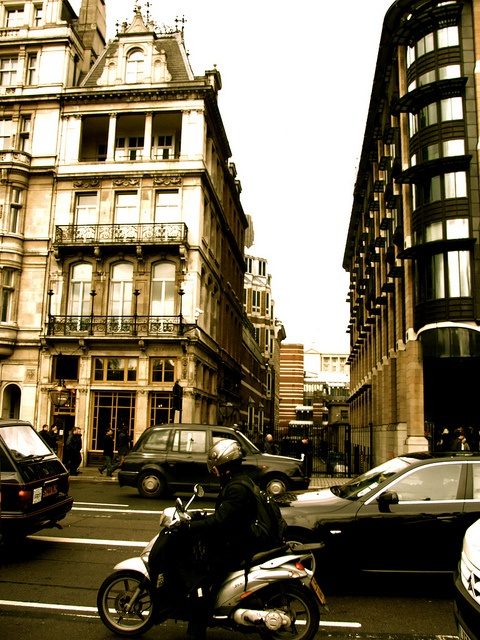Describe the objects in this image and their specific colors. I can see car in tan, black, olive, and white tones, motorcycle in tan, black, olive, and white tones, people in tan, black, olive, and ivory tones, car in tan, black, and olive tones, and car in tan, black, ivory, olive, and maroon tones in this image. 